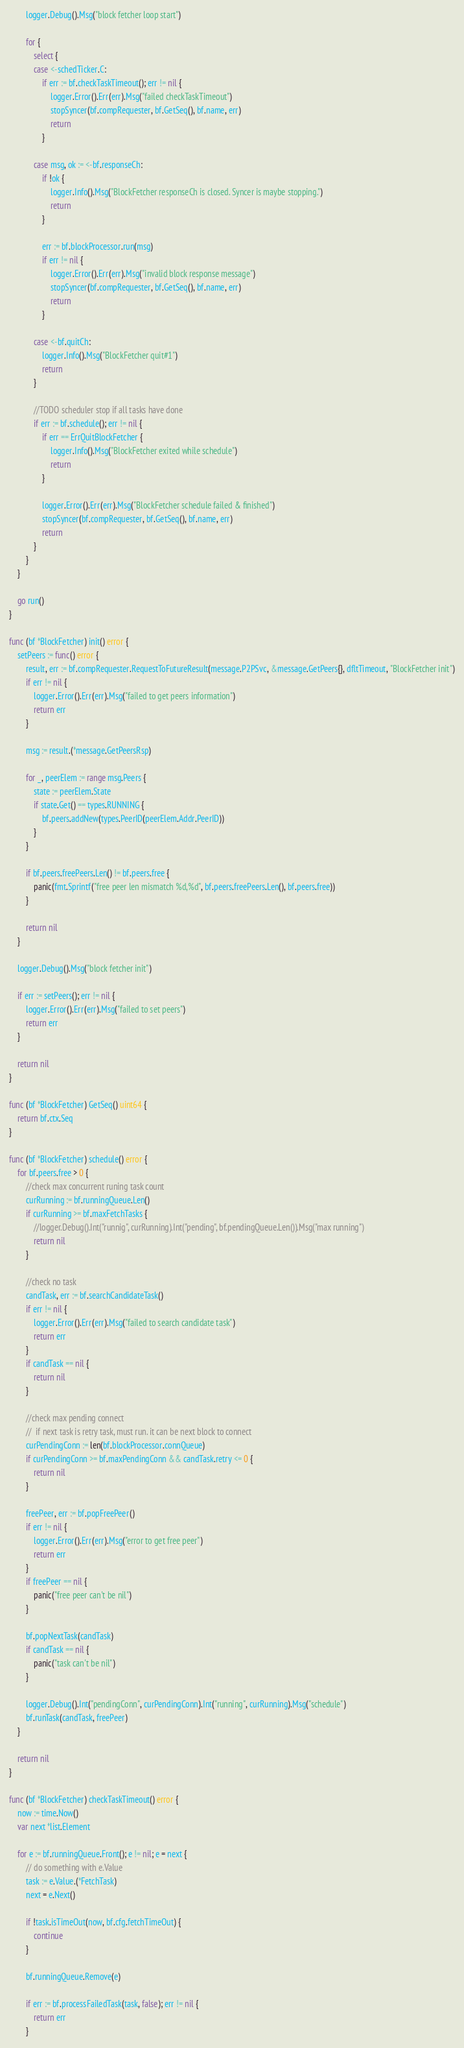<code> <loc_0><loc_0><loc_500><loc_500><_Go_>
		logger.Debug().Msg("block fetcher loop start")

		for {
			select {
			case <-schedTicker.C:
				if err := bf.checkTaskTimeout(); err != nil {
					logger.Error().Err(err).Msg("failed checkTaskTimeout")
					stopSyncer(bf.compRequester, bf.GetSeq(), bf.name, err)
					return
				}

			case msg, ok := <-bf.responseCh:
				if !ok {
					logger.Info().Msg("BlockFetcher responseCh is closed. Syncer is maybe stopping.")
					return
				}

				err := bf.blockProcessor.run(msg)
				if err != nil {
					logger.Error().Err(err).Msg("invalid block response message")
					stopSyncer(bf.compRequester, bf.GetSeq(), bf.name, err)
					return
				}

			case <-bf.quitCh:
				logger.Info().Msg("BlockFetcher quit#1")
				return
			}

			//TODO scheduler stop if all tasks have done
			if err := bf.schedule(); err != nil {
				if err == ErrQuitBlockFetcher {
					logger.Info().Msg("BlockFetcher exited while schedule")
					return
				}

				logger.Error().Err(err).Msg("BlockFetcher schedule failed & finished")
				stopSyncer(bf.compRequester, bf.GetSeq(), bf.name, err)
				return
			}
		}
	}

	go run()
}

func (bf *BlockFetcher) init() error {
	setPeers := func() error {
		result, err := bf.compRequester.RequestToFutureResult(message.P2PSvc, &message.GetPeers{}, dfltTimeout, "BlockFetcher init")
		if err != nil {
			logger.Error().Err(err).Msg("failed to get peers information")
			return err
		}

		msg := result.(*message.GetPeersRsp)

		for _, peerElem := range msg.Peers {
			state := peerElem.State
			if state.Get() == types.RUNNING {
				bf.peers.addNew(types.PeerID(peerElem.Addr.PeerID))
			}
		}

		if bf.peers.freePeers.Len() != bf.peers.free {
			panic(fmt.Sprintf("free peer len mismatch %d,%d", bf.peers.freePeers.Len(), bf.peers.free))
		}

		return nil
	}

	logger.Debug().Msg("block fetcher init")

	if err := setPeers(); err != nil {
		logger.Error().Err(err).Msg("failed to set peers")
		return err
	}

	return nil
}

func (bf *BlockFetcher) GetSeq() uint64 {
	return bf.ctx.Seq
}

func (bf *BlockFetcher) schedule() error {
	for bf.peers.free > 0 {
		//check max concurrent runing task count
		curRunning := bf.runningQueue.Len()
		if curRunning >= bf.maxFetchTasks {
			//logger.Debug().Int("runnig", curRunning).Int("pending", bf.pendingQueue.Len()).Msg("max running")
			return nil
		}

		//check no task
		candTask, err := bf.searchCandidateTask()
		if err != nil {
			logger.Error().Err(err).Msg("failed to search candidate task")
			return err
		}
		if candTask == nil {
			return nil
		}

		//check max pending connect
		//	if next task is retry task, must run. it can be next block to connect
		curPendingConn := len(bf.blockProcessor.connQueue)
		if curPendingConn >= bf.maxPendingConn && candTask.retry <= 0 {
			return nil
		}

		freePeer, err := bf.popFreePeer()
		if err != nil {
			logger.Error().Err(err).Msg("error to get free peer")
			return err
		}
		if freePeer == nil {
			panic("free peer can't be nil")
		}

		bf.popNextTask(candTask)
		if candTask == nil {
			panic("task can't be nil")
		}

		logger.Debug().Int("pendingConn", curPendingConn).Int("running", curRunning).Msg("schedule")
		bf.runTask(candTask, freePeer)
	}

	return nil
}

func (bf *BlockFetcher) checkTaskTimeout() error {
	now := time.Now()
	var next *list.Element

	for e := bf.runningQueue.Front(); e != nil; e = next {
		// do something with e.Value
		task := e.Value.(*FetchTask)
		next = e.Next()

		if !task.isTimeOut(now, bf.cfg.fetchTimeOut) {
			continue
		}

		bf.runningQueue.Remove(e)

		if err := bf.processFailedTask(task, false); err != nil {
			return err
		}
</code> 